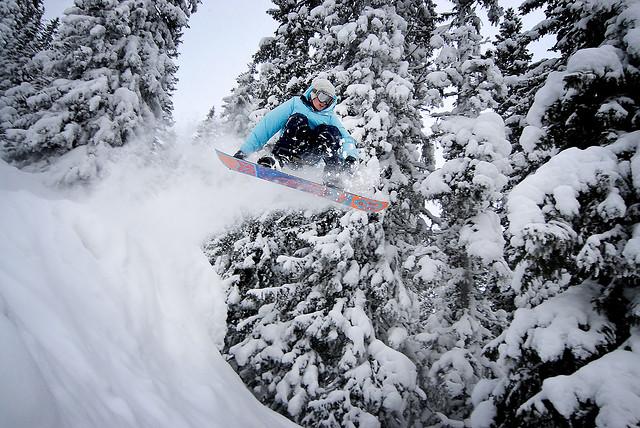Would you expect to see this in Florida?
Give a very brief answer. No. What sport is this?
Quick response, please. Snowboarding. Has it recently snowed?
Give a very brief answer. Yes. 